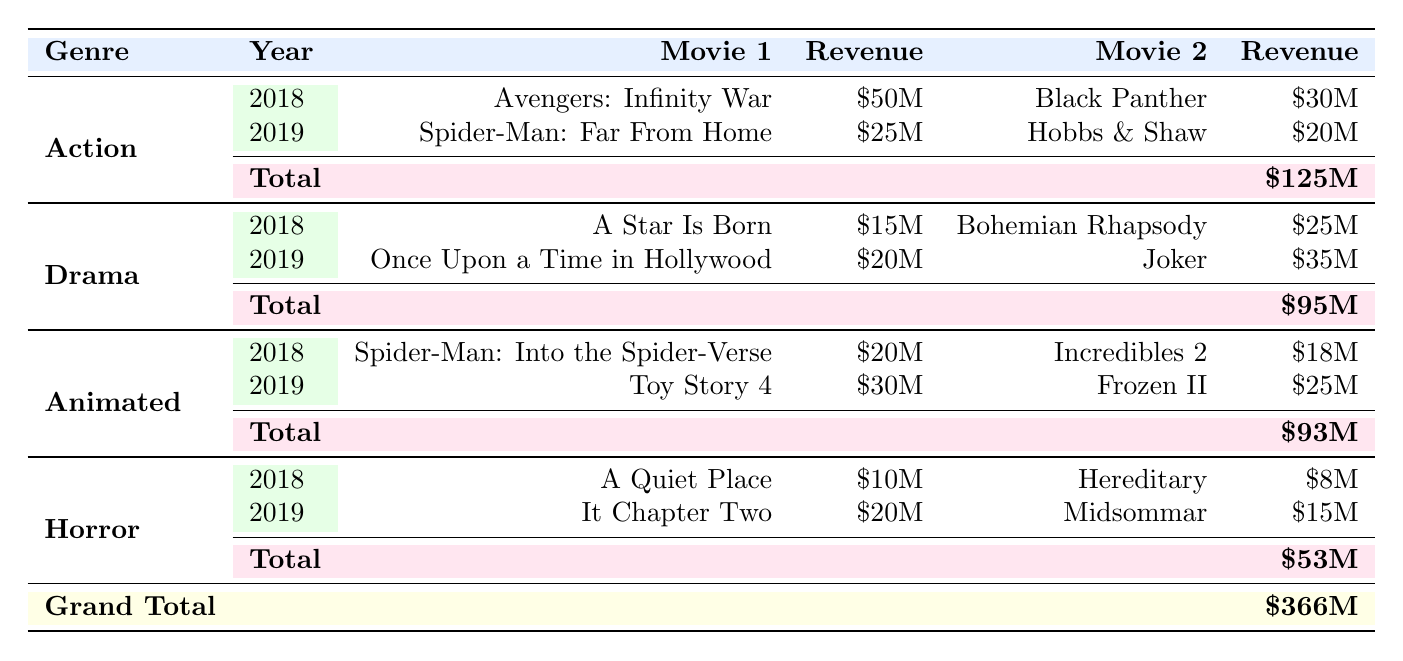What is the total revenue from Action soundtracks in 2018? The Action genre in 2018 has a total revenue of 80 million dollars as listed in the table.
Answer: 80 million Which movie earned the highest revenue in Drama for 2019? In the Drama category for 2019, the movie "Joker" earned the highest revenue of 35 million dollars, which is greater than the revenue of "Once Upon a Time in Hollywood" that earned 20 million dollars.
Answer: Joker What is the combined revenue from Animated and Horror soundtracks in 2019? The total revenue from Animated in 2019 is 55 million and from Horror is 35 million. Adding these two amounts gives 55 + 35 = 90 million dollars.
Answer: 90 million Did any Horror movie earn more than 20 million in 2018? In 2018, the highest revenue for Horror was from "A Quiet Place" and "Hereditary" with revenues of 10 million and 8 million respectively. Thus, none of the Horror movies earned more than 20 million dollars in that year.
Answer: No What genre had the highest total revenue across both years? To find the highest total revenue, we calculate it for each genre: Action is 125 million, Drama is 95 million, Animated is 93 million, and Horror is 53 million. The highest is from Action with 125 million dollars.
Answer: Action 